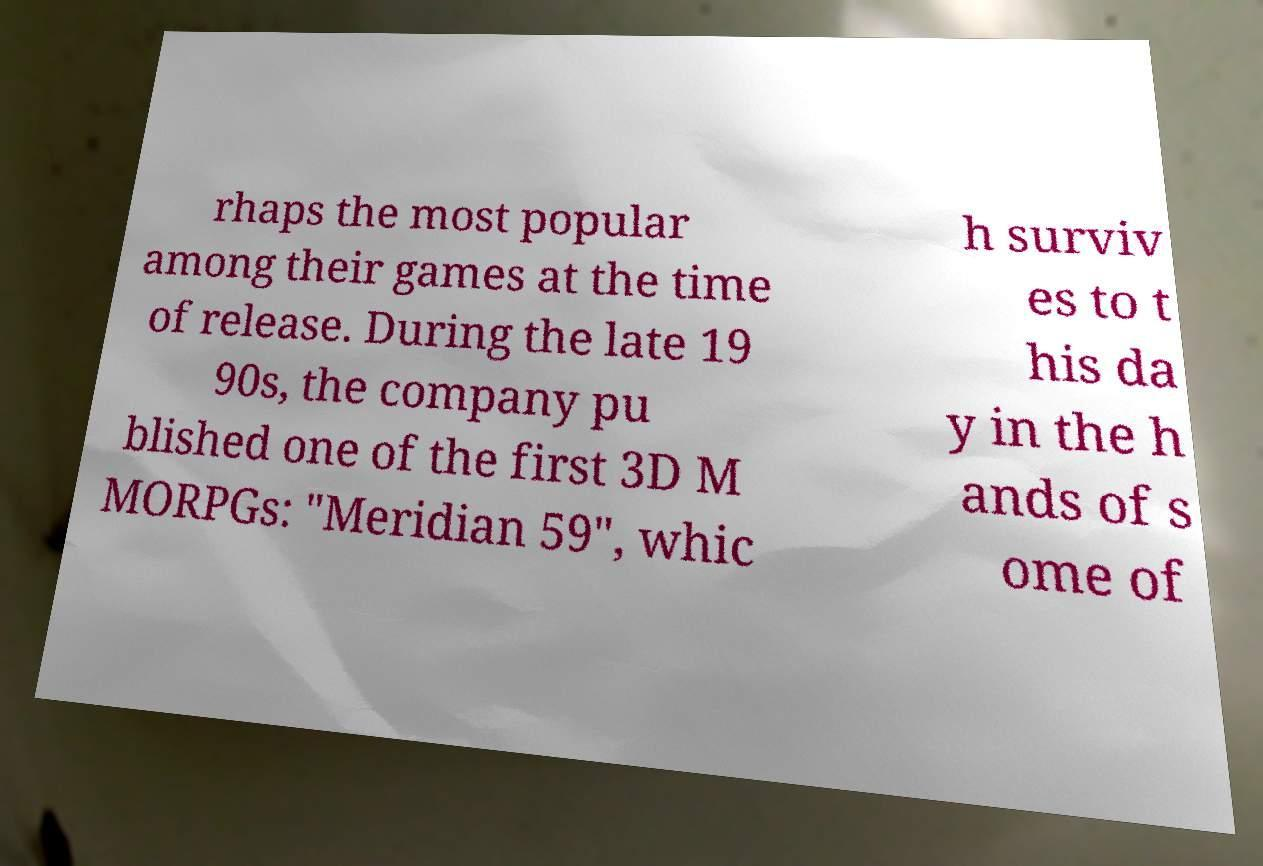There's text embedded in this image that I need extracted. Can you transcribe it verbatim? rhaps the most popular among their games at the time of release. During the late 19 90s, the company pu blished one of the first 3D M MORPGs: "Meridian 59", whic h surviv es to t his da y in the h ands of s ome of 